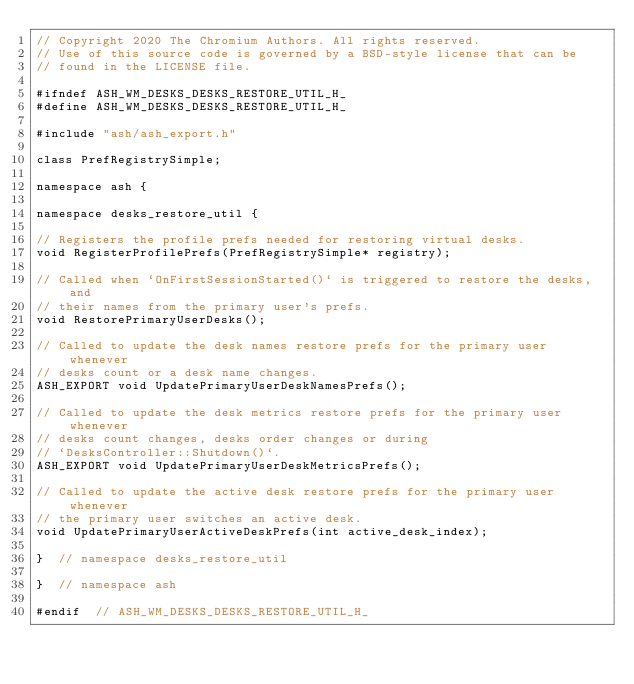<code> <loc_0><loc_0><loc_500><loc_500><_C_>// Copyright 2020 The Chromium Authors. All rights reserved.
// Use of this source code is governed by a BSD-style license that can be
// found in the LICENSE file.

#ifndef ASH_WM_DESKS_DESKS_RESTORE_UTIL_H_
#define ASH_WM_DESKS_DESKS_RESTORE_UTIL_H_

#include "ash/ash_export.h"

class PrefRegistrySimple;

namespace ash {

namespace desks_restore_util {

// Registers the profile prefs needed for restoring virtual desks.
void RegisterProfilePrefs(PrefRegistrySimple* registry);

// Called when `OnFirstSessionStarted()` is triggered to restore the desks, and
// their names from the primary user's prefs.
void RestorePrimaryUserDesks();

// Called to update the desk names restore prefs for the primary user whenever
// desks count or a desk name changes.
ASH_EXPORT void UpdatePrimaryUserDeskNamesPrefs();

// Called to update the desk metrics restore prefs for the primary user whenever
// desks count changes, desks order changes or during
// `DesksController::Shutdown()`.
ASH_EXPORT void UpdatePrimaryUserDeskMetricsPrefs();

// Called to update the active desk restore prefs for the primary user whenever
// the primary user switches an active desk.
void UpdatePrimaryUserActiveDeskPrefs(int active_desk_index);

}  // namespace desks_restore_util

}  // namespace ash

#endif  // ASH_WM_DESKS_DESKS_RESTORE_UTIL_H_
</code> 